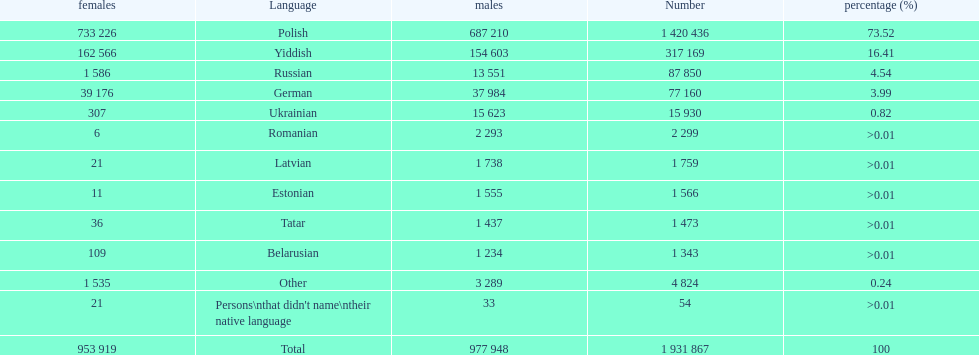What are all the languages? Polish, Yiddish, Russian, German, Ukrainian, Romanian, Latvian, Estonian, Tatar, Belarusian, Other. Which only have percentages >0.01? Romanian, Latvian, Estonian, Tatar, Belarusian. Of these, which has the greatest number of speakers? Romanian. 